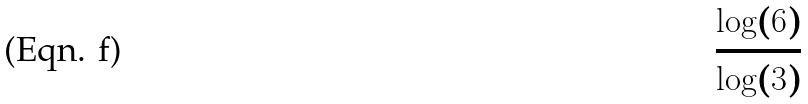Convert formula to latex. <formula><loc_0><loc_0><loc_500><loc_500>\frac { \log ( 6 ) } { \log ( 3 ) }</formula> 